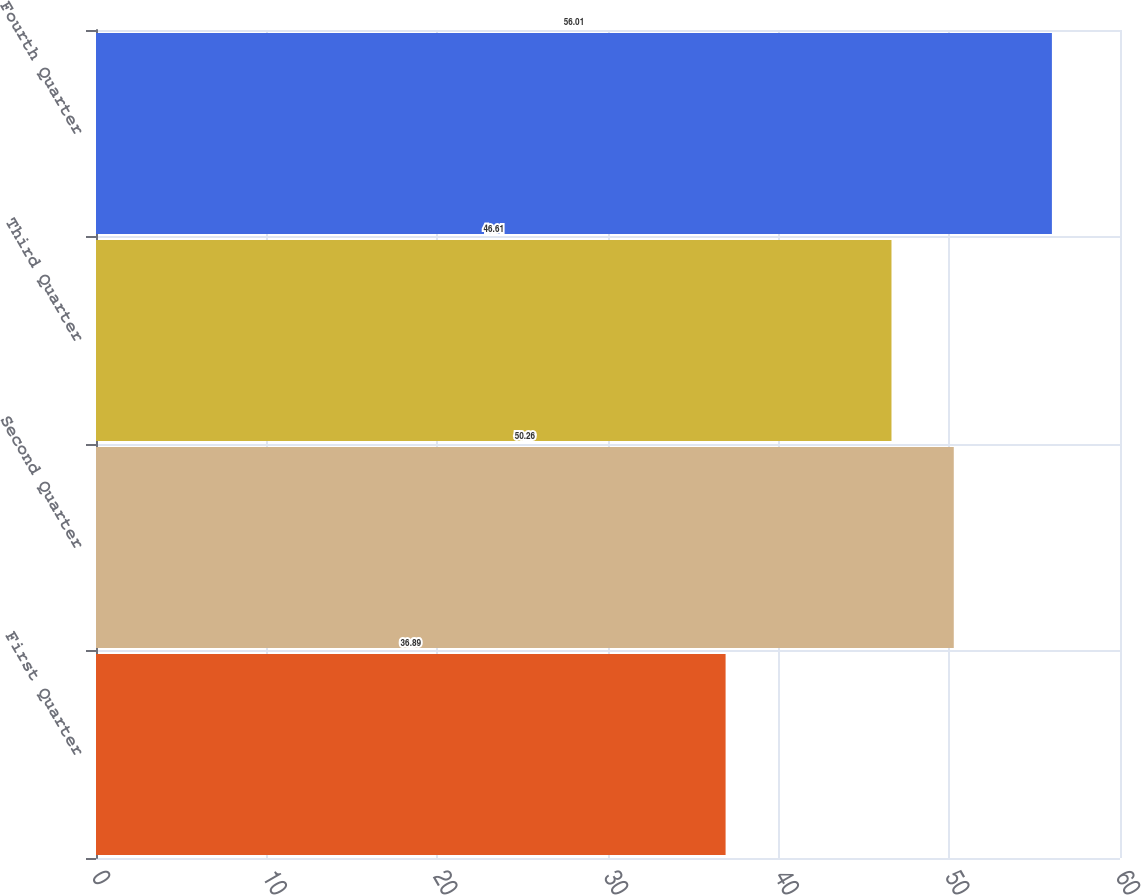<chart> <loc_0><loc_0><loc_500><loc_500><bar_chart><fcel>First Quarter<fcel>Second Quarter<fcel>Third Quarter<fcel>Fourth Quarter<nl><fcel>36.89<fcel>50.26<fcel>46.61<fcel>56.01<nl></chart> 